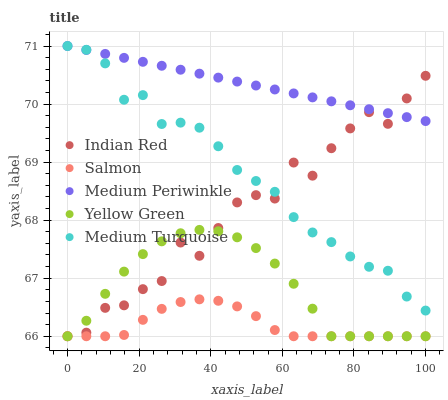Does Salmon have the minimum area under the curve?
Answer yes or no. Yes. Does Medium Periwinkle have the maximum area under the curve?
Answer yes or no. Yes. Does Medium Turquoise have the minimum area under the curve?
Answer yes or no. No. Does Medium Turquoise have the maximum area under the curve?
Answer yes or no. No. Is Medium Periwinkle the smoothest?
Answer yes or no. Yes. Is Indian Red the roughest?
Answer yes or no. Yes. Is Medium Turquoise the smoothest?
Answer yes or no. No. Is Medium Turquoise the roughest?
Answer yes or no. No. Does Salmon have the lowest value?
Answer yes or no. Yes. Does Medium Turquoise have the lowest value?
Answer yes or no. No. Does Medium Turquoise have the highest value?
Answer yes or no. Yes. Does Salmon have the highest value?
Answer yes or no. No. Is Salmon less than Medium Turquoise?
Answer yes or no. Yes. Is Medium Periwinkle greater than Salmon?
Answer yes or no. Yes. Does Indian Red intersect Medium Periwinkle?
Answer yes or no. Yes. Is Indian Red less than Medium Periwinkle?
Answer yes or no. No. Is Indian Red greater than Medium Periwinkle?
Answer yes or no. No. Does Salmon intersect Medium Turquoise?
Answer yes or no. No. 